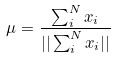<formula> <loc_0><loc_0><loc_500><loc_500>\mu = \frac { \sum _ { i } ^ { N } x _ { i } } { | | \sum _ { i } ^ { N } x _ { i } | | }</formula> 